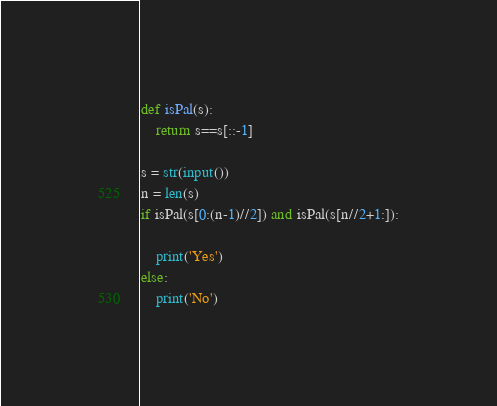Convert code to text. <code><loc_0><loc_0><loc_500><loc_500><_Python_>def isPal(s):
	return s==s[::-1]

s = str(input())
n = len(s)
if isPal(s[0:(n-1)//2]) and isPal(s[n//2+1:]):

	print('Yes')
else:
	print('No')



</code> 